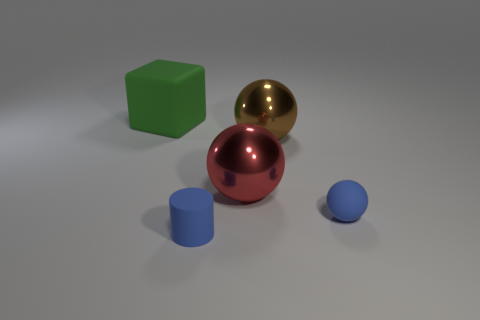There is a matte thing that is the same color as the matte ball; what is its size?
Offer a terse response. Small. There is a small matte thing that is the same color as the small sphere; what shape is it?
Your answer should be compact. Cylinder. What number of rubber objects are either tiny gray blocks or small things?
Your answer should be very brief. 2. What shape is the matte thing behind the matte thing that is to the right of the blue cylinder?
Keep it short and to the point. Cube. Is the number of brown metal spheres that are in front of the big brown metallic sphere less than the number of big cyan rubber blocks?
Your answer should be very brief. No. The brown shiny thing is what shape?
Your answer should be compact. Sphere. There is a blue thing that is in front of the small matte ball; what is its size?
Your answer should be very brief. Small. There is a matte object that is the same size as the blue matte sphere; what is its color?
Your answer should be compact. Blue. Are there any big metallic balls that have the same color as the large rubber block?
Make the answer very short. No. Are there fewer tiny blue cylinders that are on the right side of the tiny blue cylinder than big spheres that are right of the red object?
Ensure brevity in your answer.  Yes. 